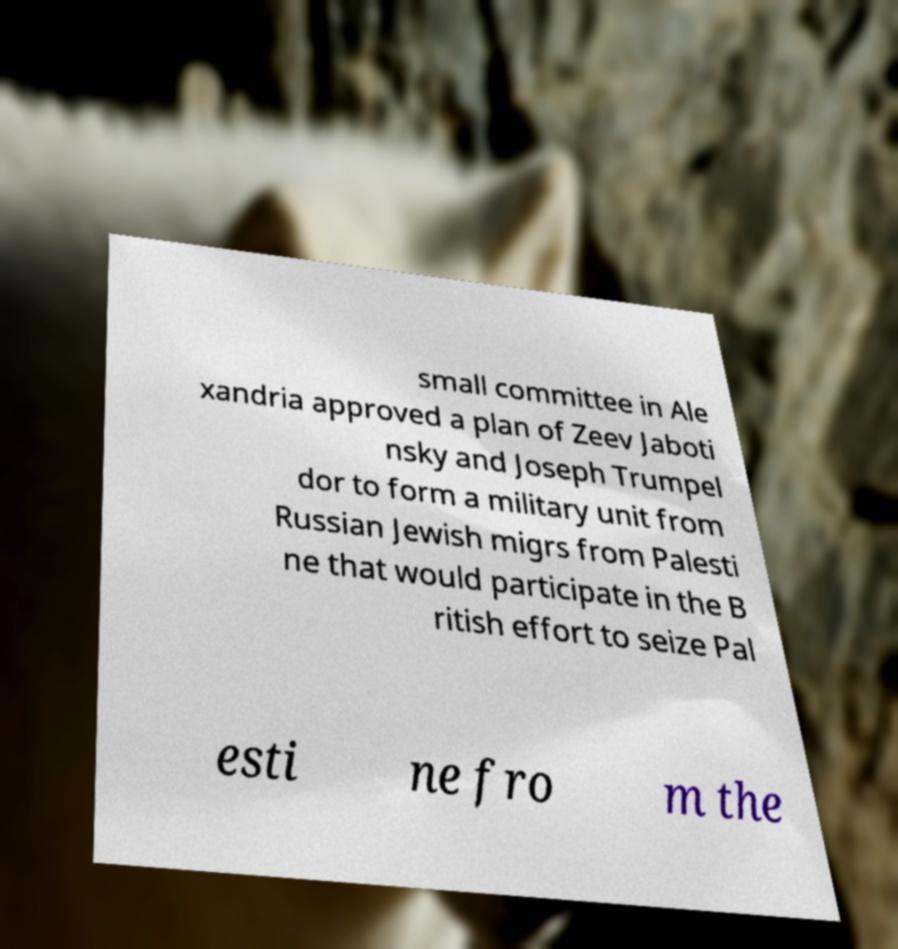What messages or text are displayed in this image? I need them in a readable, typed format. small committee in Ale xandria approved a plan of Zeev Jaboti nsky and Joseph Trumpel dor to form a military unit from Russian Jewish migrs from Palesti ne that would participate in the B ritish effort to seize Pal esti ne fro m the 